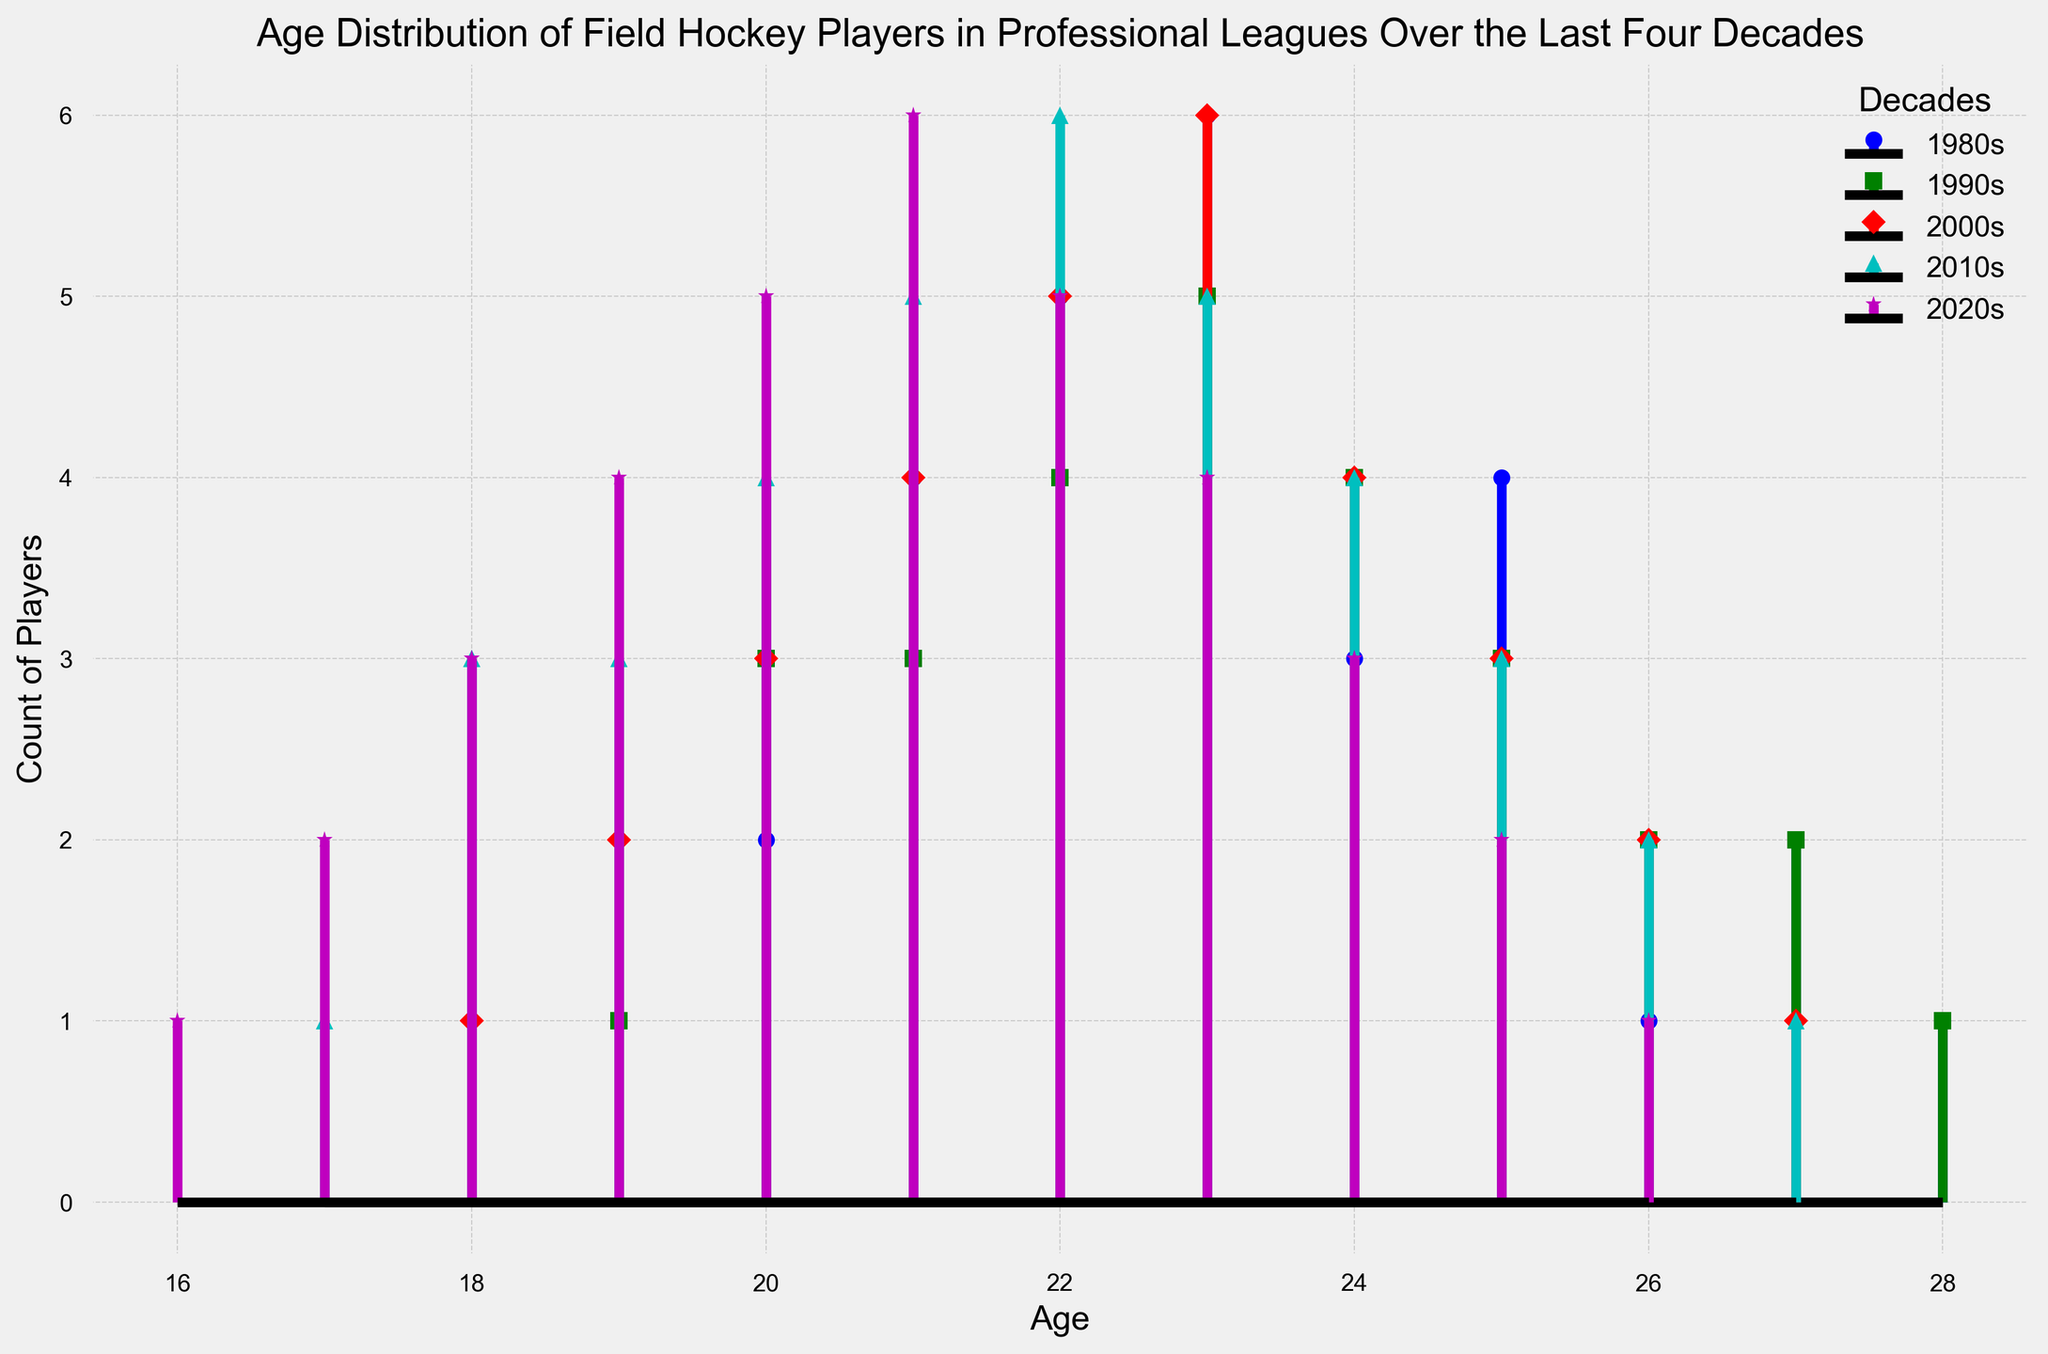What's the most common age group in the 1980s for field hockey players? In the 1980s, the age group with the highest count of players can be found by looking at the tallest stem in the plot for the 1980s. From the visual representation, the age group 23 has the highest count with a value of 6.
Answer: 23 Which decade has the most balanced age distribution among field hockey players? To determine the most balanced age distribution, we look for the decade where the heights of the stems are relatively similar across ages. The 2020s show a more balanced distribution with counts gradually decreasing from age 21 to 26.
Answer: 2020s What is the highest count of players in the 2010s, and what age does this correspond to? By identifying the tallest stem in the 2010s section of the plot, we see that the tallest stem corresponds to the age 22, which has a count of 6.
Answer: Age 22, Count 6 How does the count of 20-year-old players compare between the 2000s and the 2020s? In the plot, 20-year-olds have a stem height of 3 in the 2000s and 5 in the 2020s. By comparing, 20-year-olds in the 2020s outnumber those in the 2000s.
Answer: 2020s > 2000s What is the difference in player count between age 21 and age 25 in the 1990s? The plot shows the counts for age 21 and 25 in the 1990s. Age 21 has a count of 3, and age 25 has a count of 3. The difference is 0.
Answer: 0 How many age groups have more than 4 players in the 2010s? In the 2010s, we need to count the stems with heights greater than 4: ages 21 and 22. Therefore, there are 2 such age groups.
Answer: 2 Which age group appears in all decades, and what is their trend? By observing the stems across all decades, age 22 appears in all decades. The trend shows the count of players at age 22 has been steadily increasing, peaking in the 2010s.
Answer: Age 22, Increasing Which decade has the steepest decline in player count after age 23? The 1980s show the steepest decline post age 23, where the counts drop sharply from 6 at age 23 to 3 at age 24.
Answer: 1980s Is the youngest player's age decreasing over the decades? If so, by how much? The youngest player's age each decade is: 20 in the 1980s, 19 in the 1990s, 18 in the 2000s, 17 in the 2010s, and 16 in the 2020s. The decrease is by 4 years from 20 to 16.
Answer: Yes, by 4 years 